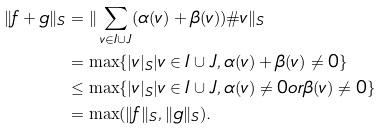Convert formula to latex. <formula><loc_0><loc_0><loc_500><loc_500>\| f + g \| _ { S } & = \| \sum _ { v \in I \cup J } ( \alpha ( v ) + \beta ( v ) ) \# v \| _ { S } \\ & = \max \{ | v | _ { S } | v \in I \cup J , \alpha ( v ) + \beta ( v ) \neq 0 \} \\ & \leq \max \{ | v | _ { S } | v \in I \cup J , \alpha ( v ) \neq 0 o r \beta ( v ) \neq 0 \} \\ & = \max ( \| f \| _ { S } , \| g \| _ { S } ) .</formula> 